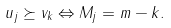<formula> <loc_0><loc_0><loc_500><loc_500>u _ { j } \succeq v _ { k } \Leftrightarrow M _ { j } = m - k .</formula> 